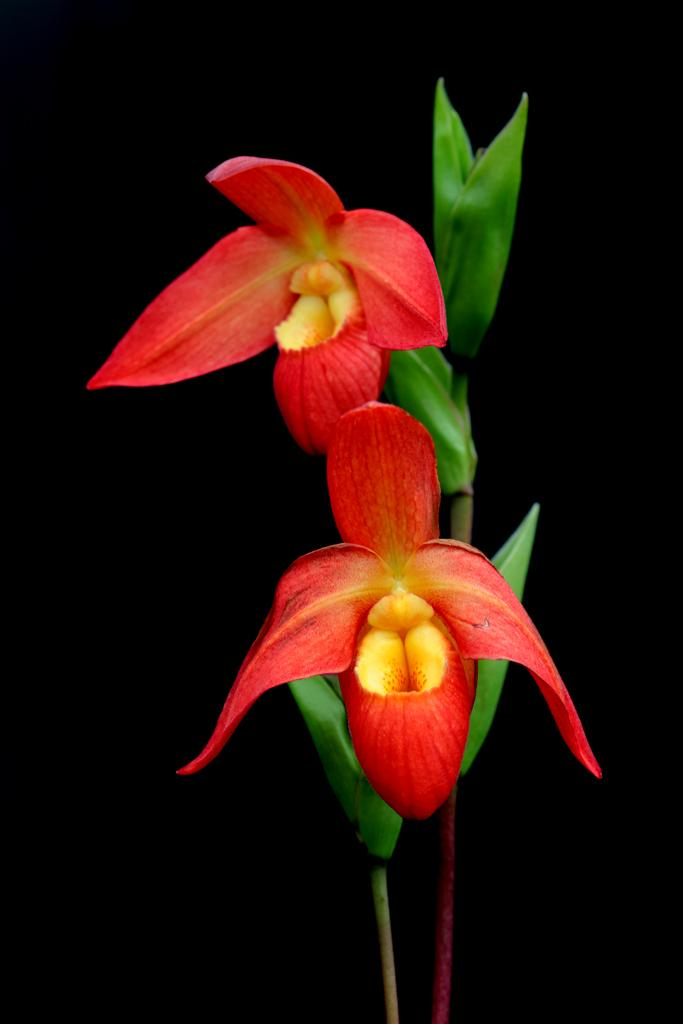How many flowers can be seen in the image? There are two flowers in the image. What are the colors of the flowers? One flower is red in color, and the other is yellow in color. What else can be seen in the image besides the flowers? There are leaves in the image. What is the color of the leaves? The leaves are green in color. How would you describe the background of the image? The background of the image is dark. What type of smile can be seen on the flowers in the image? There are no smiles present on the flowers in the image, as flowers do not have facial expressions. Where is the lunchroom located in the image? There is no lunchroom present in the image; it features two flowers and leaves. 